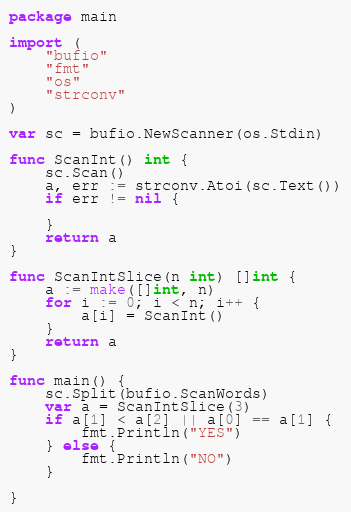Convert code to text. <code><loc_0><loc_0><loc_500><loc_500><_Go_>package main

import (
	"bufio"
	"fmt"
	"os"
	"strconv"
)

var sc = bufio.NewScanner(os.Stdin)

func ScanInt() int {
	sc.Scan()
	a, err := strconv.Atoi(sc.Text())
	if err != nil {

	}
	return a
}

func ScanIntSlice(n int) []int {
	a := make([]int, n)
	for i := 0; i < n; i++ {
		a[i] = ScanInt()
	}
	return a
}

func main() {
	sc.Split(bufio.ScanWords)
	var a = ScanIntSlice(3)
	if a[1] < a[2] || a[0] == a[1] {
		fmt.Println("YES")
	} else {
		fmt.Println("NO")
	}

}
</code> 